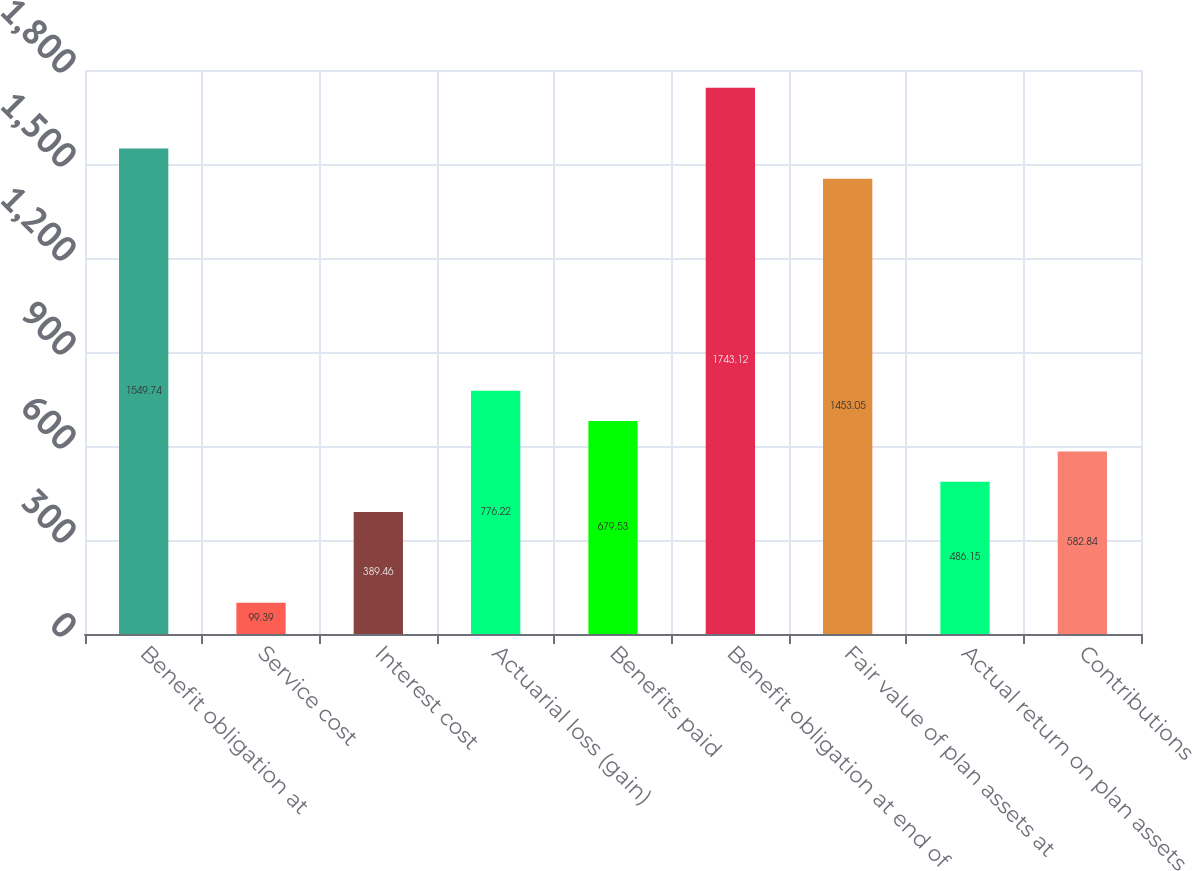Convert chart to OTSL. <chart><loc_0><loc_0><loc_500><loc_500><bar_chart><fcel>Benefit obligation at<fcel>Service cost<fcel>Interest cost<fcel>Actuarial loss (gain)<fcel>Benefits paid<fcel>Benefit obligation at end of<fcel>Fair value of plan assets at<fcel>Actual return on plan assets<fcel>Contributions<nl><fcel>1549.74<fcel>99.39<fcel>389.46<fcel>776.22<fcel>679.53<fcel>1743.12<fcel>1453.05<fcel>486.15<fcel>582.84<nl></chart> 